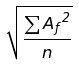<formula> <loc_0><loc_0><loc_500><loc_500>\sqrt { \frac { \sum { A _ { f } } ^ { 2 } } { n } }</formula> 